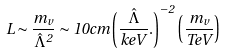<formula> <loc_0><loc_0><loc_500><loc_500>L \sim \frac { m _ { v } } { \hat { \Lambda } ^ { 2 } } \sim 1 0 c m \left ( \frac { \hat { \Lambda } } { k e V } . \right ) ^ { - 2 } \left ( \frac { m _ { v } } { T e V } \right )</formula> 